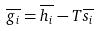<formula> <loc_0><loc_0><loc_500><loc_500>\overline { g _ { i } } = \overline { h _ { i } } - T \overline { s _ { i } }</formula> 